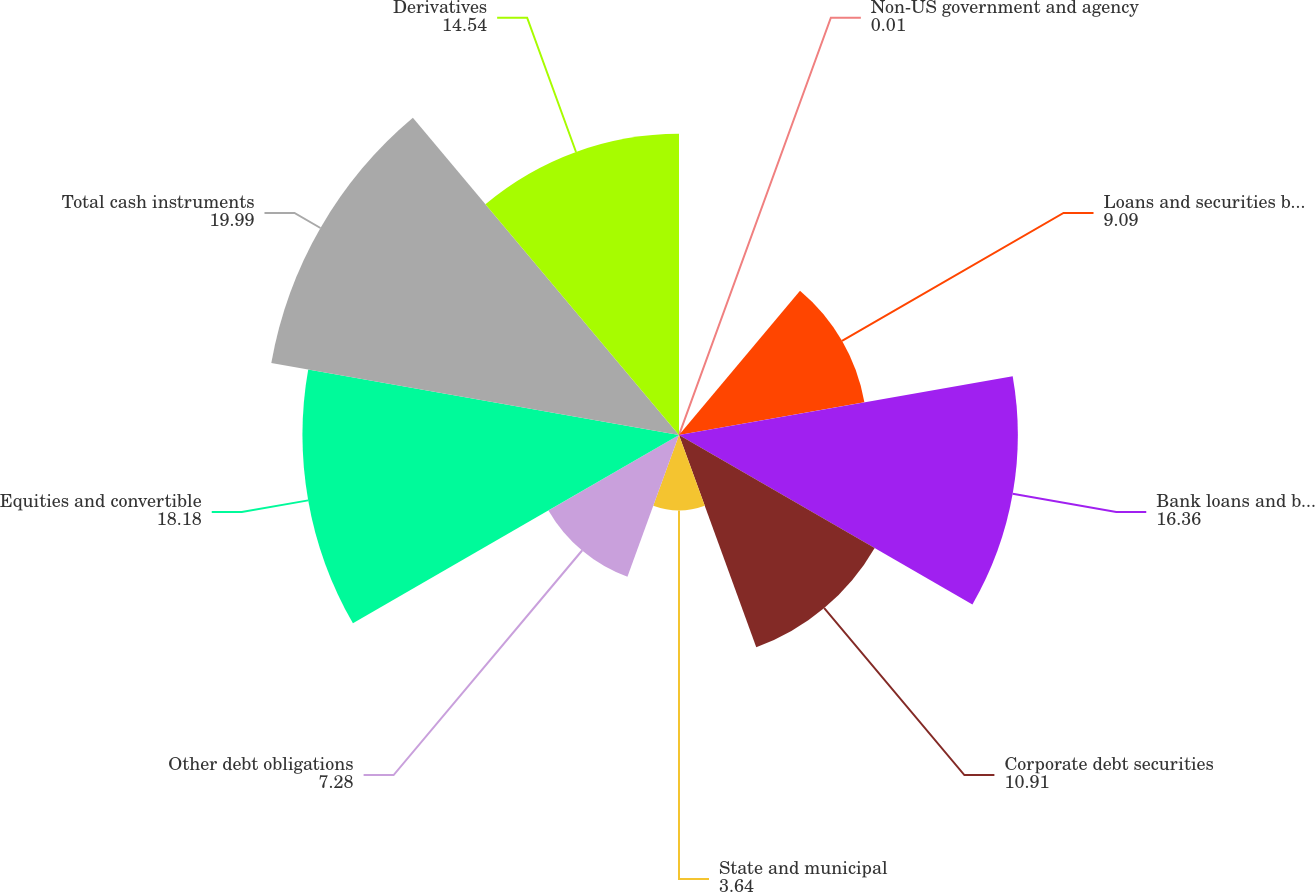Convert chart to OTSL. <chart><loc_0><loc_0><loc_500><loc_500><pie_chart><fcel>Non-US government and agency<fcel>Loans and securities backed by<fcel>Bank loans and bridge loans<fcel>Corporate debt securities<fcel>State and municipal<fcel>Other debt obligations<fcel>Equities and convertible<fcel>Total cash instruments<fcel>Derivatives<nl><fcel>0.01%<fcel>9.09%<fcel>16.36%<fcel>10.91%<fcel>3.64%<fcel>7.28%<fcel>18.18%<fcel>19.99%<fcel>14.54%<nl></chart> 